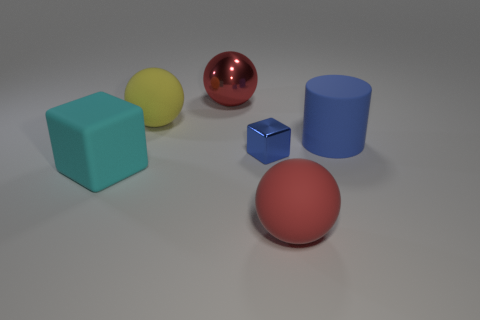What can the positioning of these objects tell us? The arrangement of the objects may suggest a deliberate composition, possibly for a visual study in perspective or to compare how different shapes and colors interact with light. The placement seems spaced out to avoid overlap in the visual field, allowing each object's form and color to be clearly observed without interference from the others. 